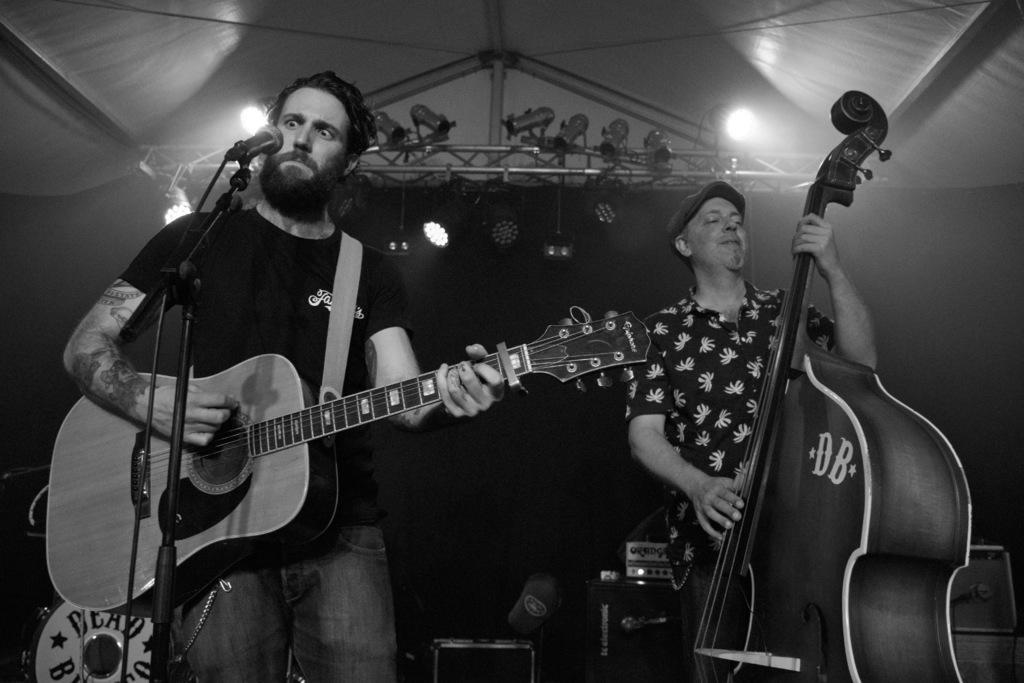Could you give a brief overview of what you see in this image? This picture is taken on a stage and it is black and white. There are two persons holding musical instruments. A man towards the left, he is playing a guitar and staring at a mike before him. Towards the right there is another man, he is playing a musical instrument. In the background there is a stage with lights. 